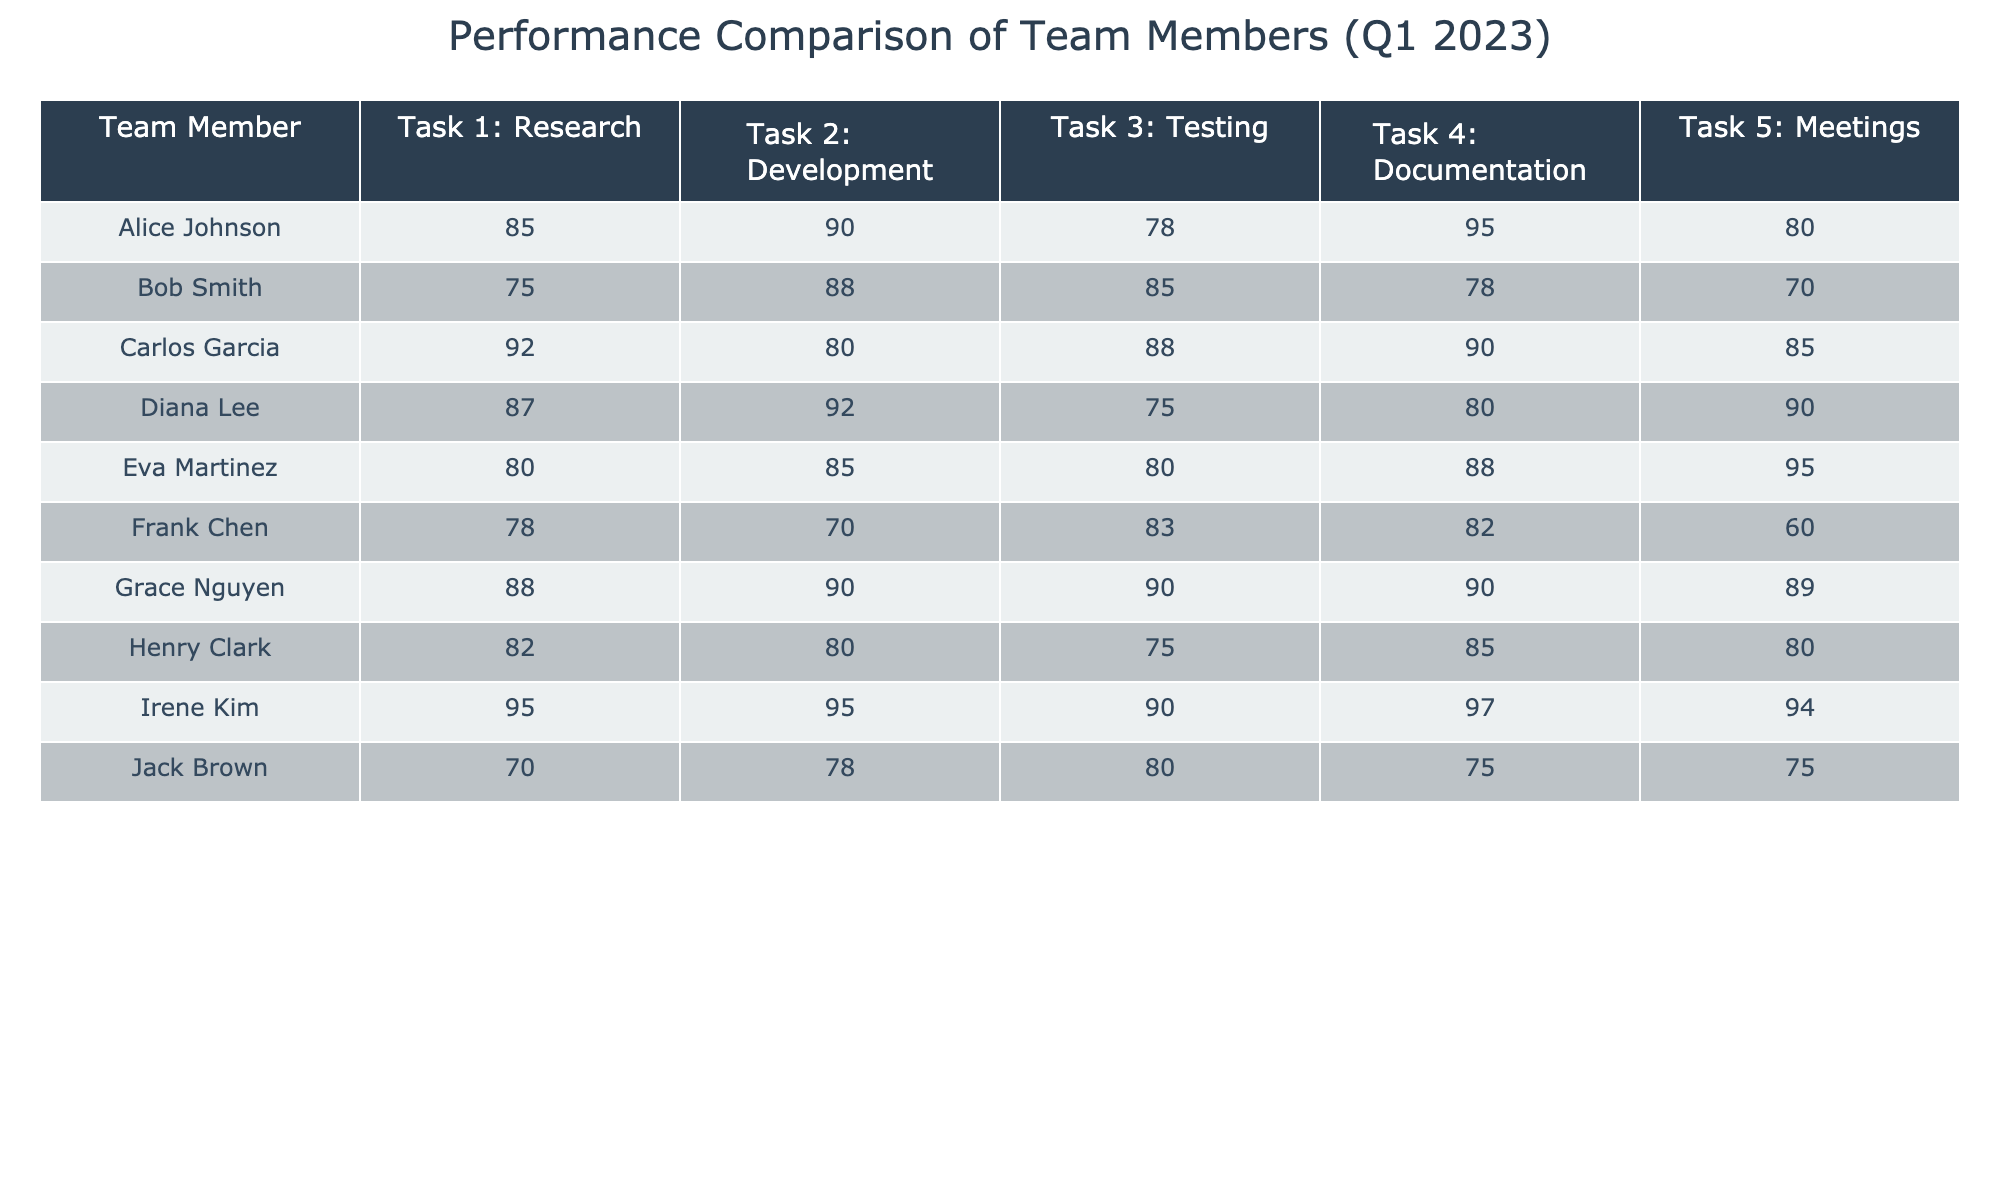What was the highest score in Task 3: Testing? In the table, I look for the maximum value under Task 3: Testing. Scanning through the values, I see the highest score is 90, achieved by Irene Kim and Grace Nguyen.
Answer: 90 Who scored the lowest in Task 1: Research? Checking the values in Task 1: Research, I find Frank Chen has the lowest score of 78 compared to the other team members.
Answer: 78 What is the average score for Bob Smith across all tasks? To calculate Bob Smith's average score, I sum his scores: 75 + 88 + 85 + 78 + 70 = 396. Then, I divide by the total number of tasks (5) to get the average: 396 / 5 = 79.2.
Answer: 79.2 Did any team member score above 90 in Task 2: Development? I examine the scores in Task 2: Development and find that the highest score is 92, which belongs to Diana Lee and Irene Kim, confirming that at least two members scored above 90.
Answer: Yes What is the difference in scores between the highest and lowest for Task 4: Documentation? First, I identify the highest score in Task 4: Documentation, which is 97 (Irene Kim) and the lowest, which is 75 (Jack Brown). The difference is calculated as 97 - 75 = 22.
Answer: 22 Calculate the median score for Task 5: Meetings. First, I list the scores for Task 5: Meetings: [80, 70, 85, 90, 95, 60, 89, 80, 94, 75]. Then, I sort these scores: [60, 70, 75, 80, 80, 85, 89, 90, 94, 95]. Since there are 10 scores, the median is the average of the 5th and 6th scores: (80 + 85) / 2 = 82.5.
Answer: 82.5 Who performed better in Task 3: Testing, Carlos Garcia or Eva Martinez? I compare their scores: Carlos Garcia scored 88 and Eva Martinez scored 80 in Task 3: Testing. Since 88 is greater than 80, Carlos Garcia performed better.
Answer: Carlos Garcia What percentage of tasks did Grace Nguyen score above 85? Grace Nguyen scored above 85 in Tasks 1 (88), 2 (90), 3 (90), and 4 (90), totaling 4 tasks. She completed 5 tasks overall. The percentage is (4/5) * 100 = 80%.
Answer: 80% Who had a higher average, Irene Kim or Frank Chen? First, I calculate Irene Kim's average: (95 + 95 + 90 + 97 + 94) = 471, and dividing by 5 gives 94.2. Then, for Frank Chen: (78 + 70 + 83 + 82 + 60) = 373, and dividing by 5 gives 74.6. Comparing these, Irene Kim has a higher average.
Answer: Irene Kim Which team member participated in the most meetings based on their Task 5 score? I check the scores under Task 5: Meetings and find Eva Martinez with a score of 95, which is the highest compared to others.
Answer: Eva Martinez 